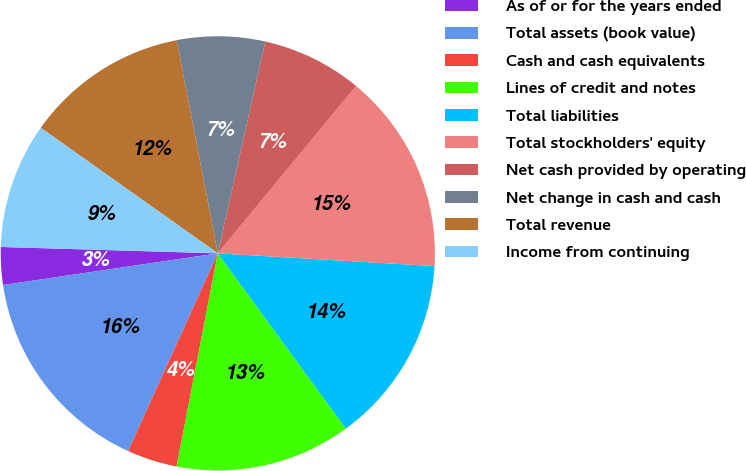Convert chart. <chart><loc_0><loc_0><loc_500><loc_500><pie_chart><fcel>As of or for the years ended<fcel>Total assets (book value)<fcel>Cash and cash equivalents<fcel>Lines of credit and notes<fcel>Total liabilities<fcel>Total stockholders' equity<fcel>Net cash provided by operating<fcel>Net change in cash and cash<fcel>Total revenue<fcel>Income from continuing<nl><fcel>2.8%<fcel>15.89%<fcel>3.74%<fcel>13.08%<fcel>14.02%<fcel>14.95%<fcel>7.48%<fcel>6.54%<fcel>12.15%<fcel>9.35%<nl></chart> 